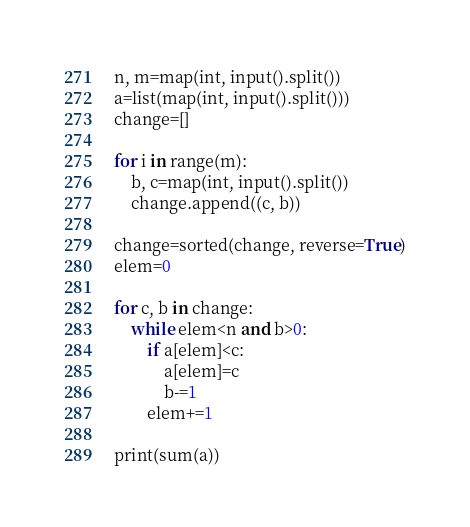<code> <loc_0><loc_0><loc_500><loc_500><_Python_>n, m=map(int, input().split())
a=list(map(int, input().split()))
change=[]

for i in range(m):
    b, c=map(int, input().split())
    change.append((c, b))

change=sorted(change, reverse=True)
elem=0

for c, b in change:
    while elem<n and b>0:
        if a[elem]<c:
            a[elem]=c
            b-=1
        elem+=1

print(sum(a))</code> 